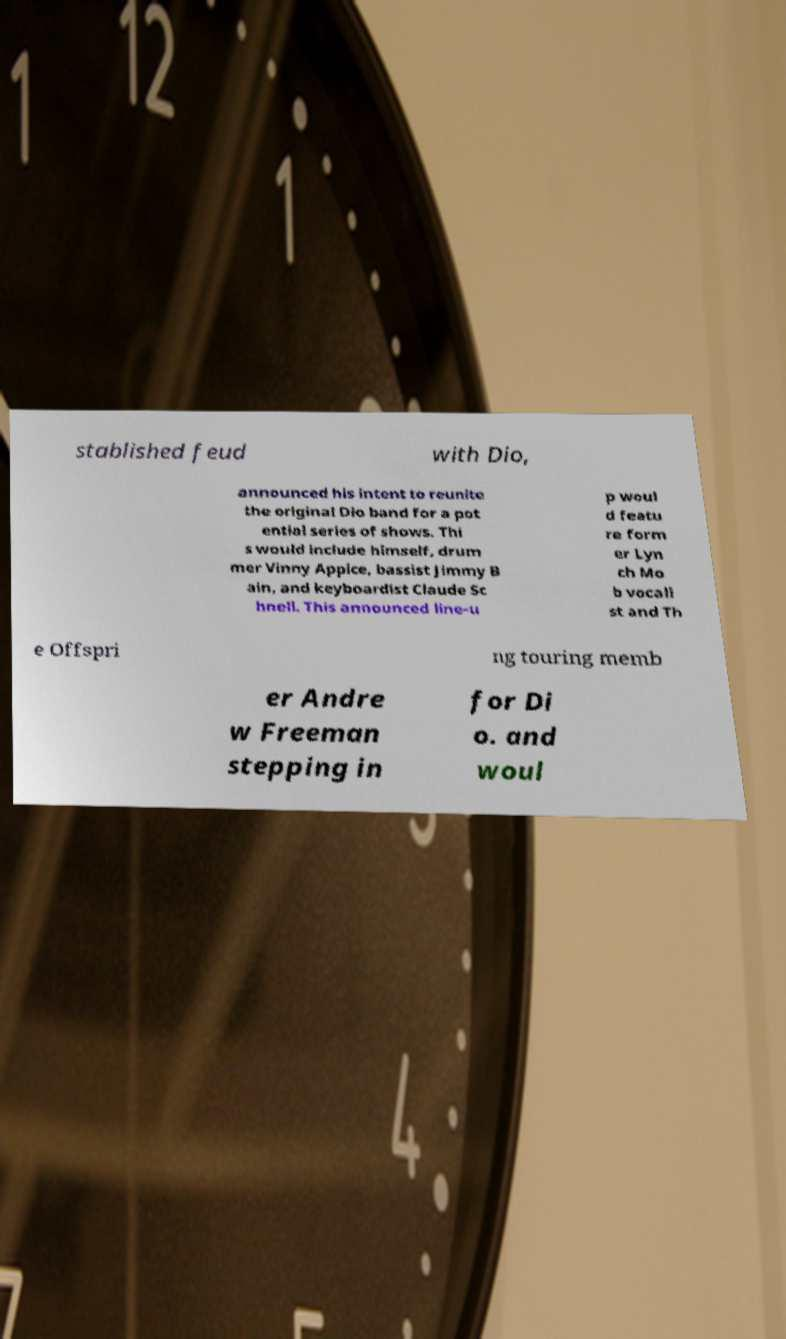Could you extract and type out the text from this image? stablished feud with Dio, announced his intent to reunite the original Dio band for a pot ential series of shows. Thi s would include himself, drum mer Vinny Appice, bassist Jimmy B ain, and keyboardist Claude Sc hnell. This announced line-u p woul d featu re form er Lyn ch Mo b vocali st and Th e Offspri ng touring memb er Andre w Freeman stepping in for Di o. and woul 